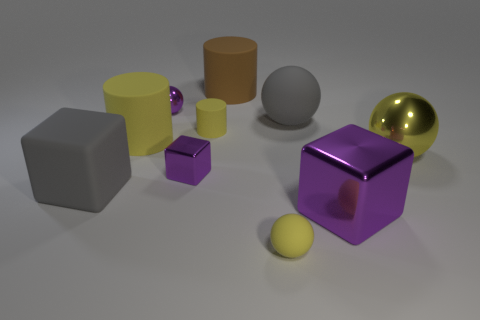Is the color of the large matte ball the same as the big rubber block?
Your answer should be compact. Yes. Is the material of the large gray cube the same as the brown cylinder?
Your answer should be very brief. Yes. How big is the rubber thing that is on the right side of the gray block and left of the small purple ball?
Keep it short and to the point. Large. What is the shape of the large brown object?
Ensure brevity in your answer.  Cylinder. How many things are either gray metallic things or balls behind the large purple block?
Ensure brevity in your answer.  3. There is a cube that is in front of the gray cube; is it the same color as the tiny shiny cube?
Provide a short and direct response. Yes. What is the color of the matte thing that is both in front of the small yellow cylinder and to the right of the brown matte object?
Provide a succinct answer. Yellow. There is a ball in front of the large purple block; what is its material?
Your response must be concise. Rubber. How big is the purple sphere?
Your answer should be compact. Small. How many purple objects are either things or metal spheres?
Give a very brief answer. 3. 